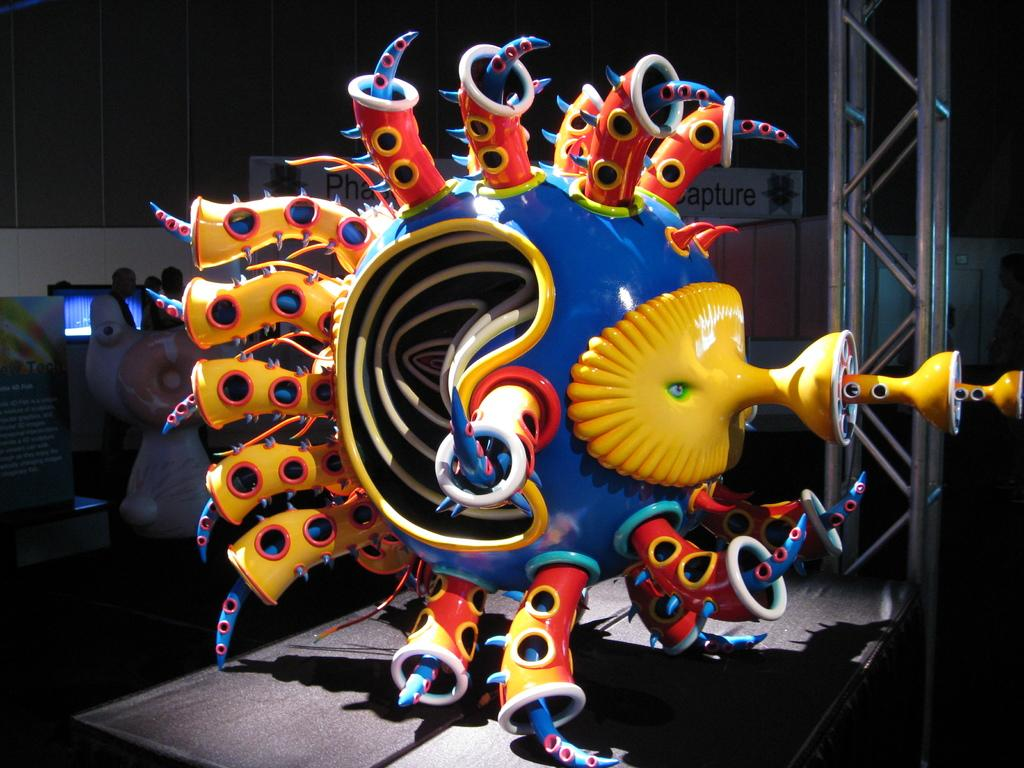What type of objects are on the ground in the image? There are decorated toys on the ground. What other objects can be seen in the image? There are poles and posters with text in the image. What is the color of the background in the image? The background of the image is dark. What type of music can be heard playing in the background of the image? There is no music present in the image, as it only contains visual elements. 